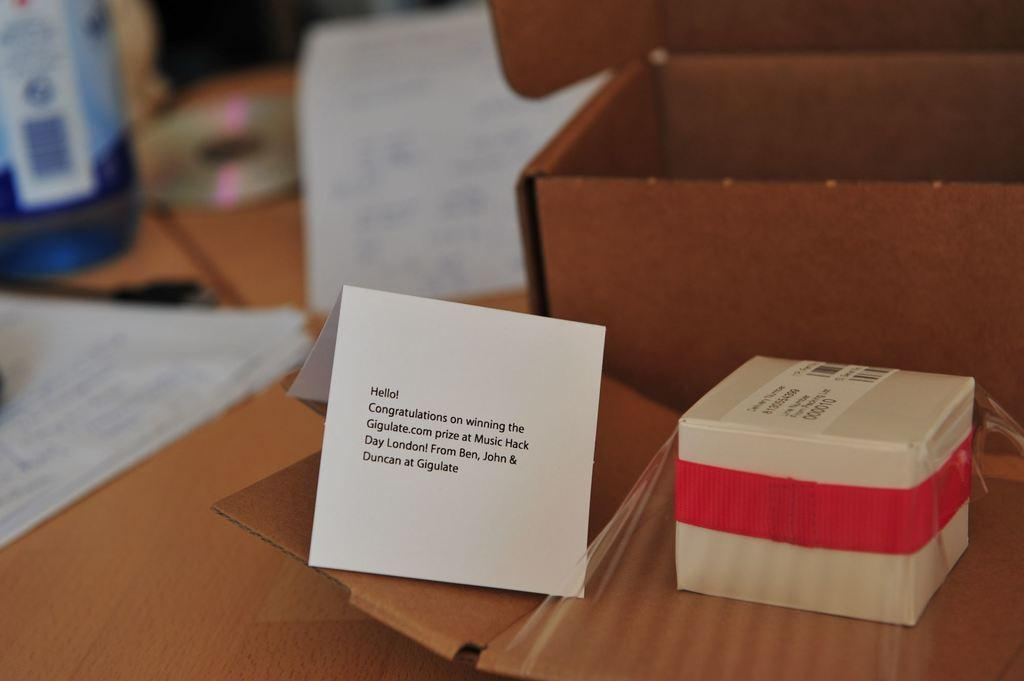What type of objects can be seen in the image? There are papers, cardboard boxes, a CD disk, and a water bottle in the image. What material are the cardboard boxes made of? The cardboard boxes are made of cardboard. What is the medium of the CD disk? The CD disk is a digital storage medium. What is the container for the water in the image? The water is contained in a water bottle. On what surface are the objects placed? The objects are placed on a wooden object. Can you see any feet or toes in the image? No, there are no feet or toes present in the image. What type of plants can be seen growing in the image? There are no plants visible in the image. 